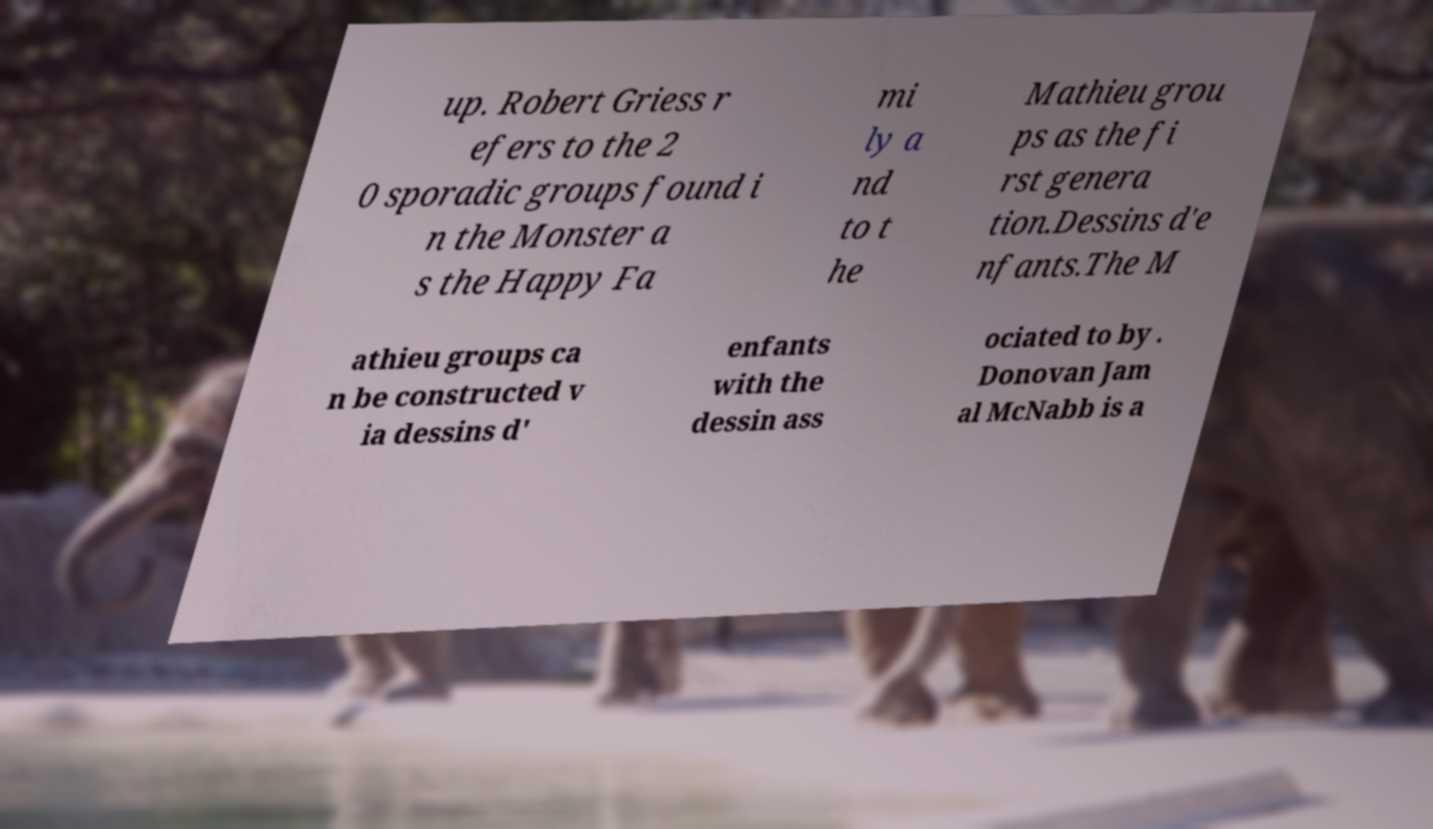Can you read and provide the text displayed in the image?This photo seems to have some interesting text. Can you extract and type it out for me? up. Robert Griess r efers to the 2 0 sporadic groups found i n the Monster a s the Happy Fa mi ly a nd to t he Mathieu grou ps as the fi rst genera tion.Dessins d'e nfants.The M athieu groups ca n be constructed v ia dessins d' enfants with the dessin ass ociated to by . Donovan Jam al McNabb is a 